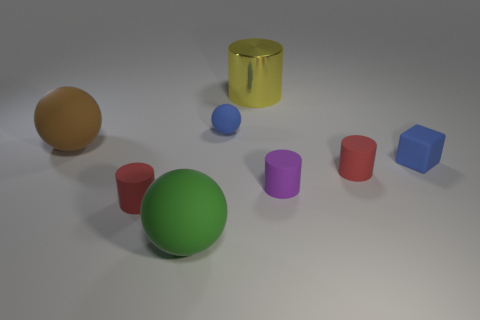Subtract all tiny rubber balls. How many balls are left? 2 Add 2 big brown spheres. How many objects exist? 10 Subtract 2 cylinders. How many cylinders are left? 2 Subtract all cyan blocks. Subtract all yellow cylinders. How many blocks are left? 1 Subtract all yellow cylinders. How many green balls are left? 1 Subtract all small red matte cylinders. Subtract all large cylinders. How many objects are left? 5 Add 6 large metal cylinders. How many large metal cylinders are left? 7 Add 8 brown objects. How many brown objects exist? 9 Subtract all red cylinders. How many cylinders are left? 2 Subtract 0 gray cylinders. How many objects are left? 8 